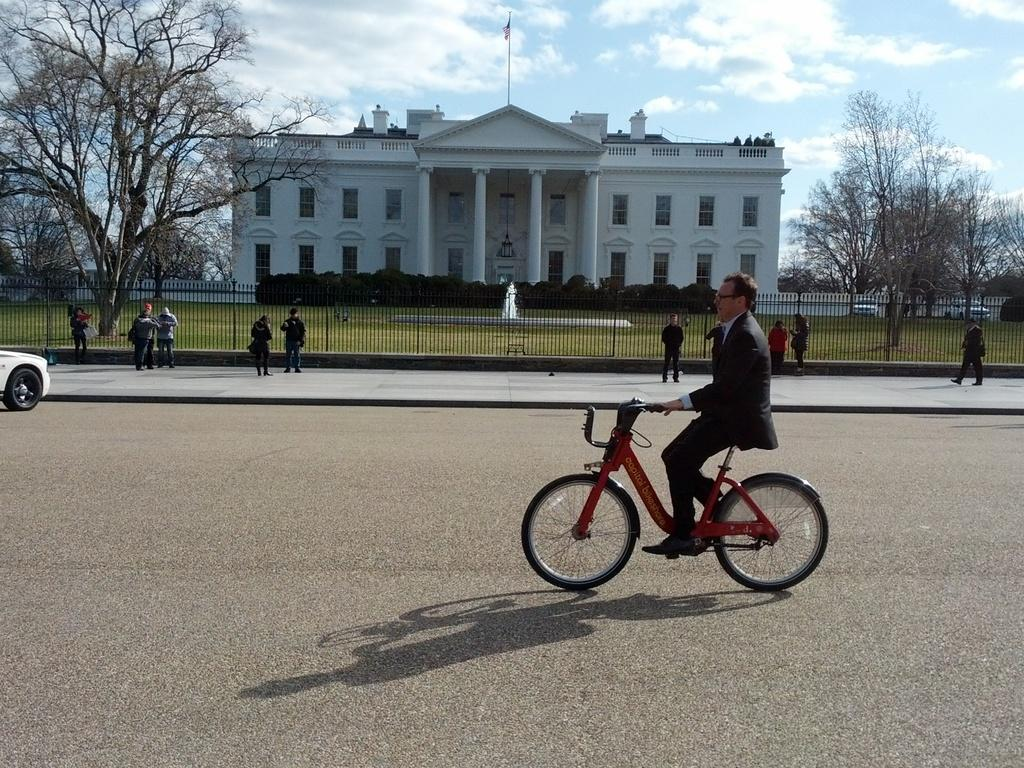What is the main subject of the image? There is a guy riding a bicycle in the image. What can be seen in the background of the image? There are people standing in the background of the image, and there is a beautiful white building. Is there an umbrella being used by the guy riding the bicycle in the image? There is no mention of an umbrella in the image, so it cannot be determined if the guy is using one. 